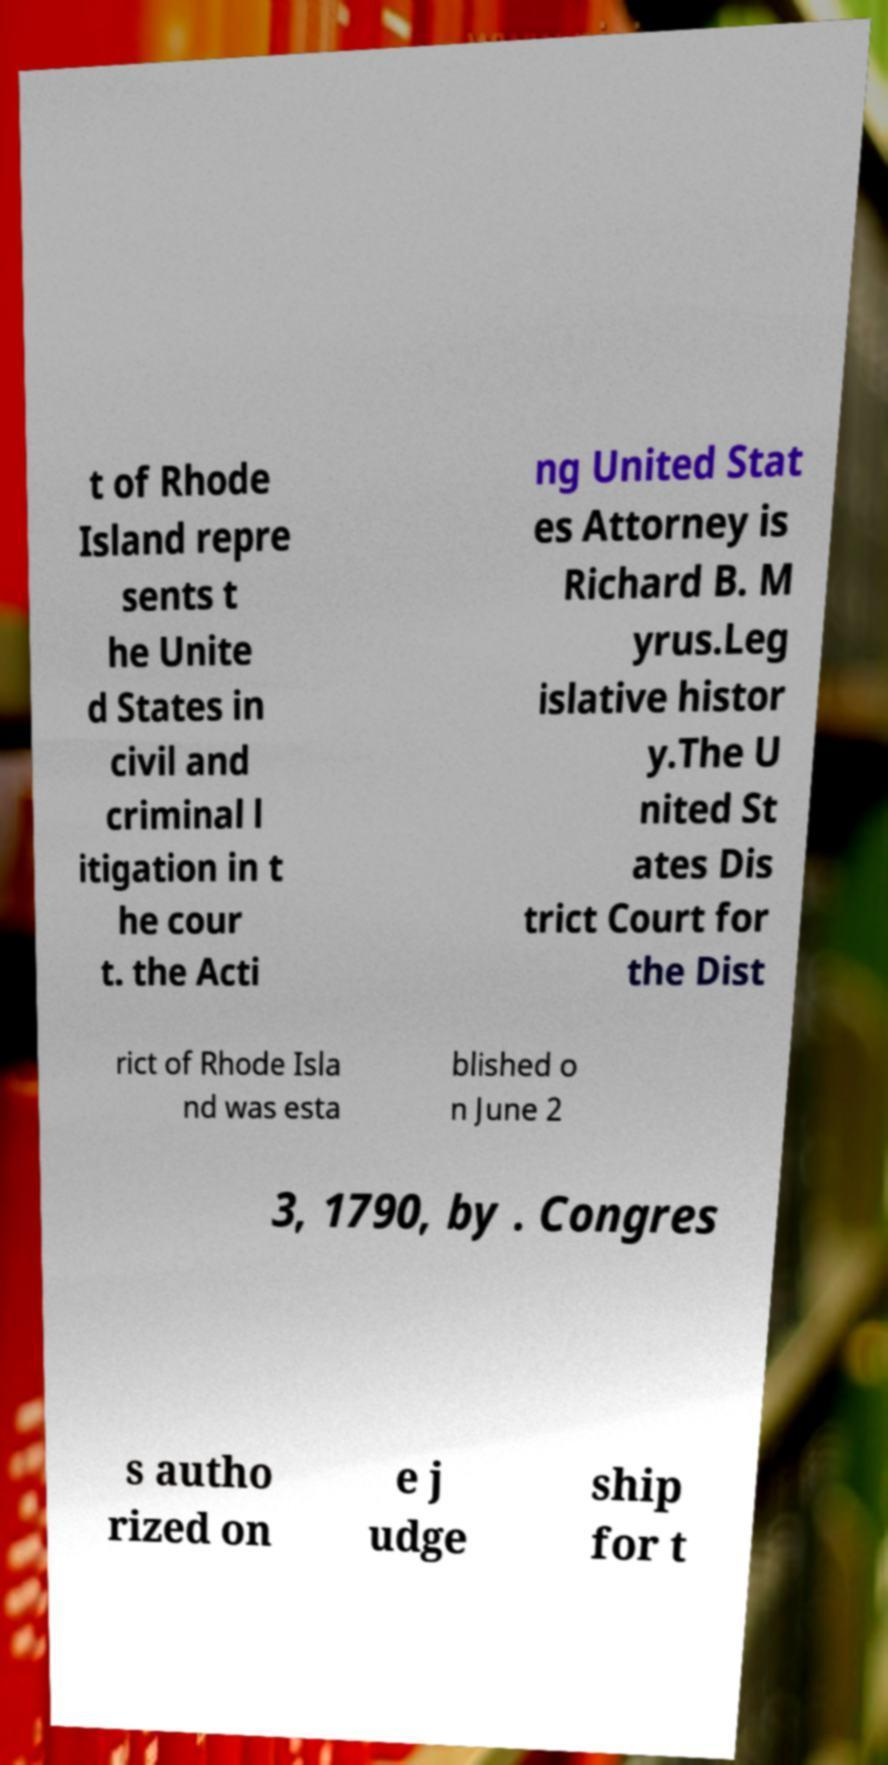There's text embedded in this image that I need extracted. Can you transcribe it verbatim? t of Rhode Island repre sents t he Unite d States in civil and criminal l itigation in t he cour t. the Acti ng United Stat es Attorney is Richard B. M yrus.Leg islative histor y.The U nited St ates Dis trict Court for the Dist rict of Rhode Isla nd was esta blished o n June 2 3, 1790, by . Congres s autho rized on e j udge ship for t 